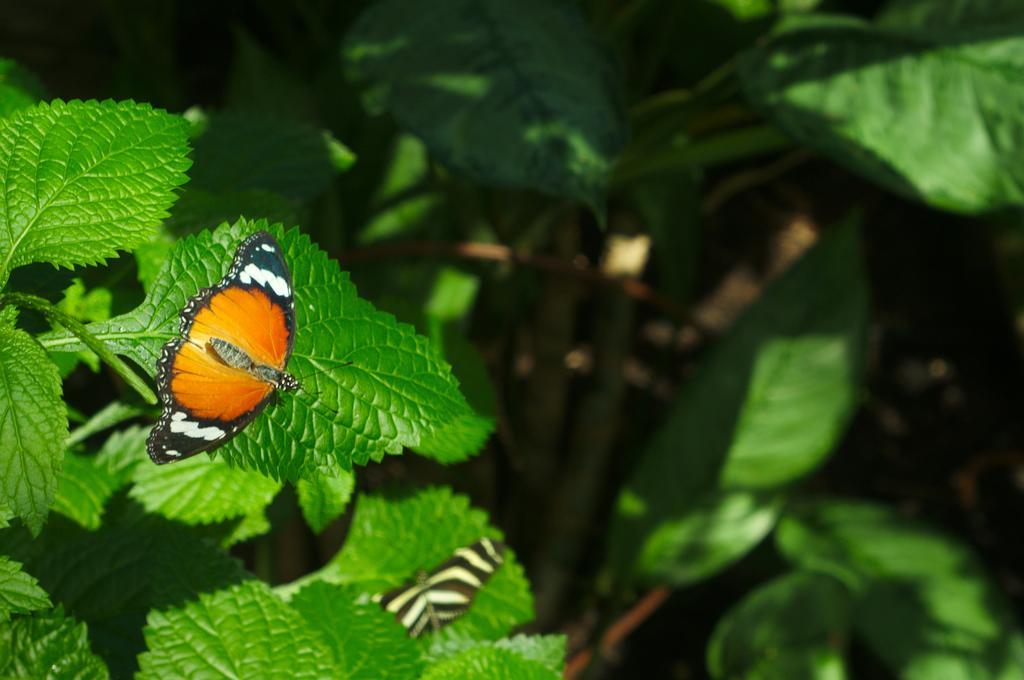Please provide a concise description of this image. In this image there are butterflies on leaves, behind them there are leaves with stems. 